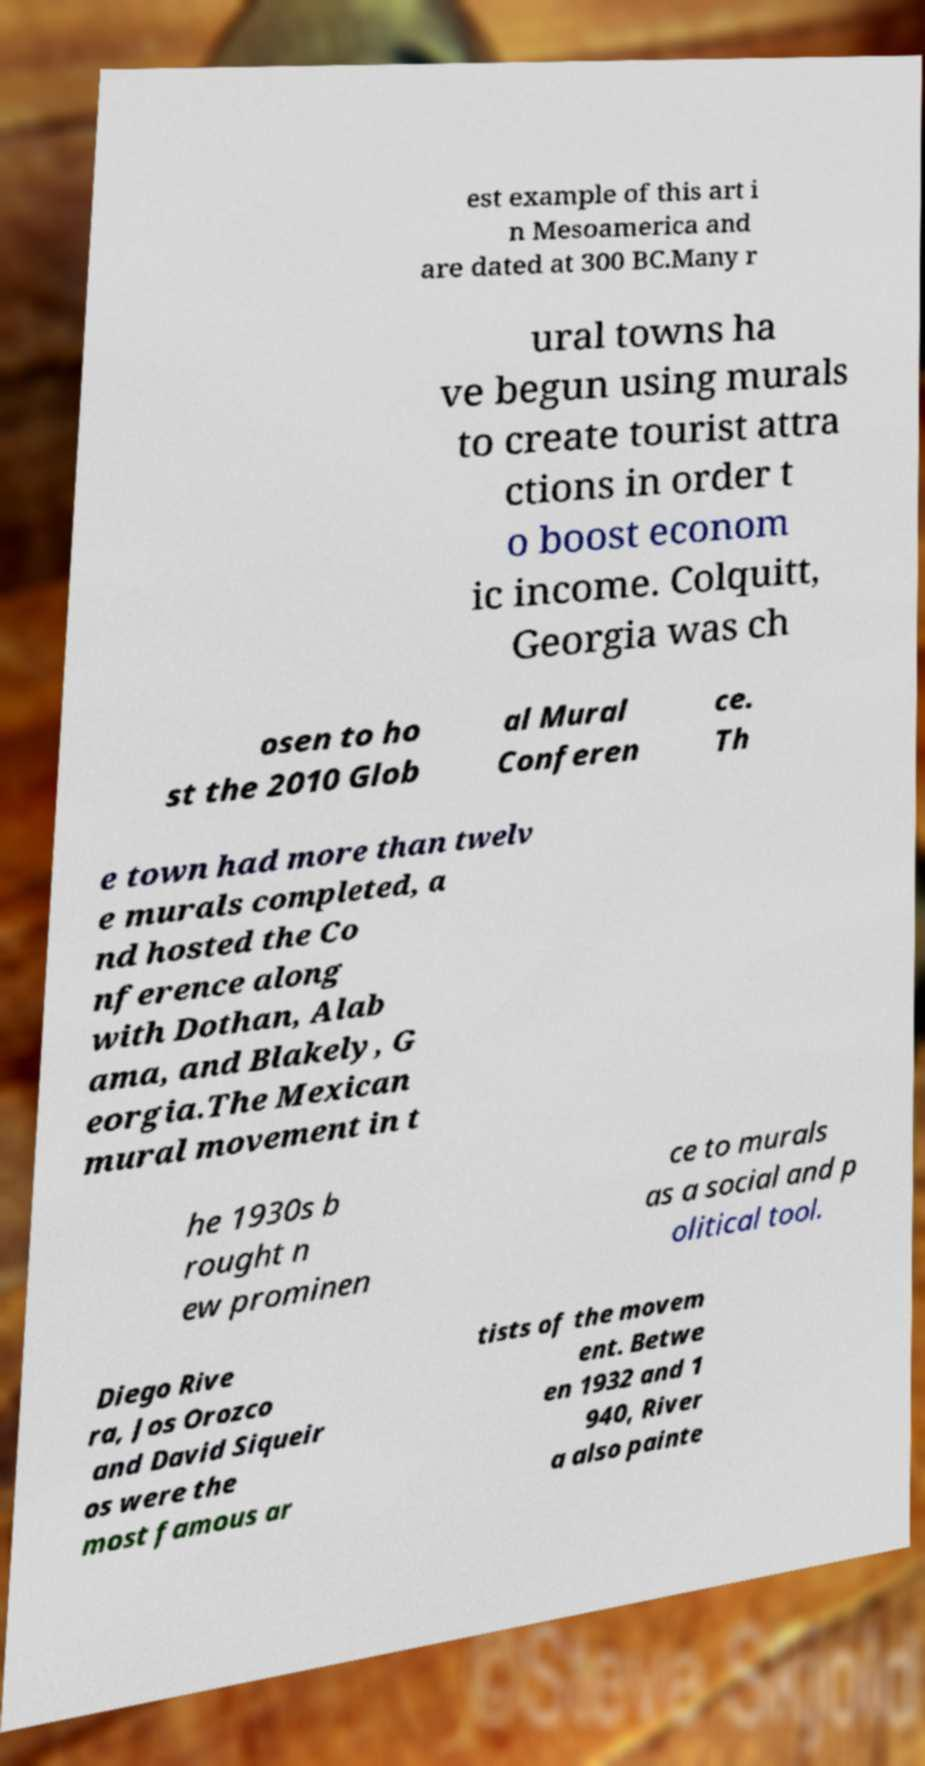Can you accurately transcribe the text from the provided image for me? est example of this art i n Mesoamerica and are dated at 300 BC.Many r ural towns ha ve begun using murals to create tourist attra ctions in order t o boost econom ic income. Colquitt, Georgia was ch osen to ho st the 2010 Glob al Mural Conferen ce. Th e town had more than twelv e murals completed, a nd hosted the Co nference along with Dothan, Alab ama, and Blakely, G eorgia.The Mexican mural movement in t he 1930s b rought n ew prominen ce to murals as a social and p olitical tool. Diego Rive ra, Jos Orozco and David Siqueir os were the most famous ar tists of the movem ent. Betwe en 1932 and 1 940, River a also painte 